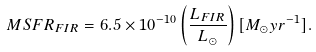Convert formula to latex. <formula><loc_0><loc_0><loc_500><loc_500>M S F R _ { F I R } = 6 . 5 \times 1 0 ^ { - 1 0 } \left ( \frac { L _ { F I R } } { L _ { \odot } } \right ) [ M _ { \odot } y r ^ { - 1 } ] .</formula> 